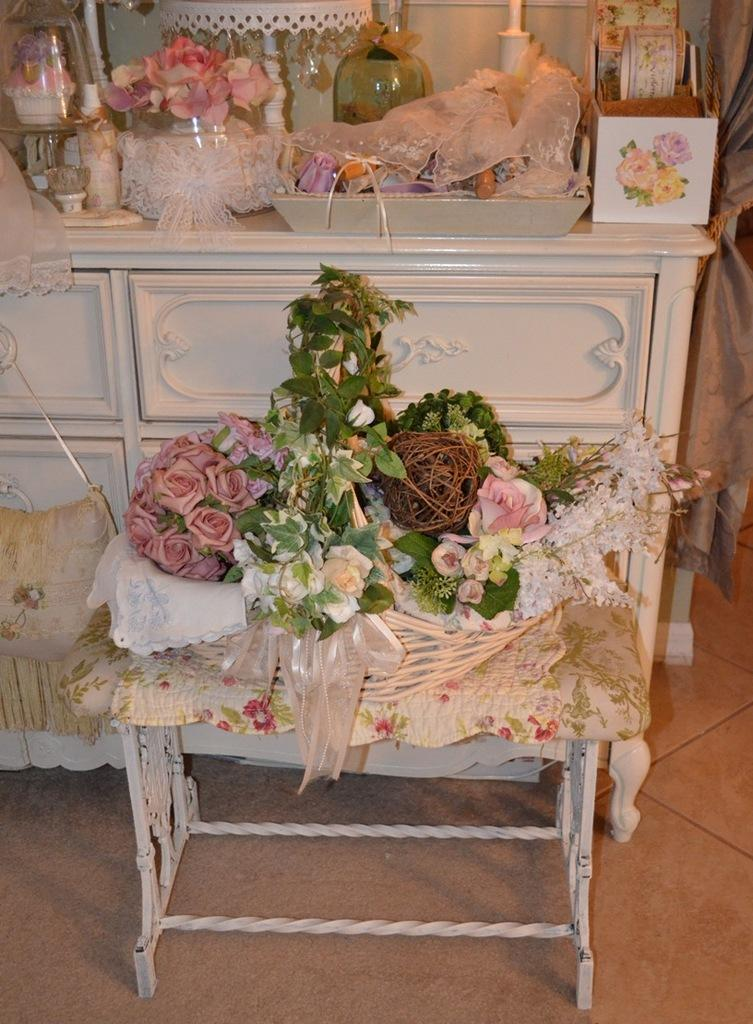What object related to reading can be seen in the image? There is a book in the image. What is the purpose of the tray in the image? The tray is likely used for holding or organizing items. What provides light in the image? There is a lamp in the image. What type of decorative or natural elements are present in the image? There are flowers and bouquets on the table in the image. How many bridges can be seen crossing the river in the image? There is no river or bridge present in the image. What type of coat is draped over the chair in the image? There is no coat or chair present in the image. 